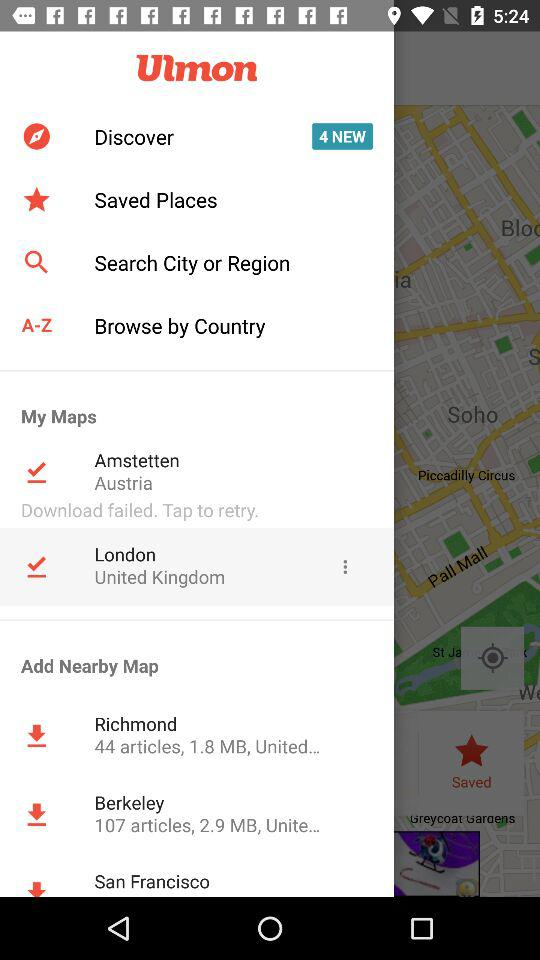How many articles are there in "Berkeley"? There are 107 articles in "Berkeley". 